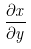<formula> <loc_0><loc_0><loc_500><loc_500>\frac { \partial x } { \partial y }</formula> 